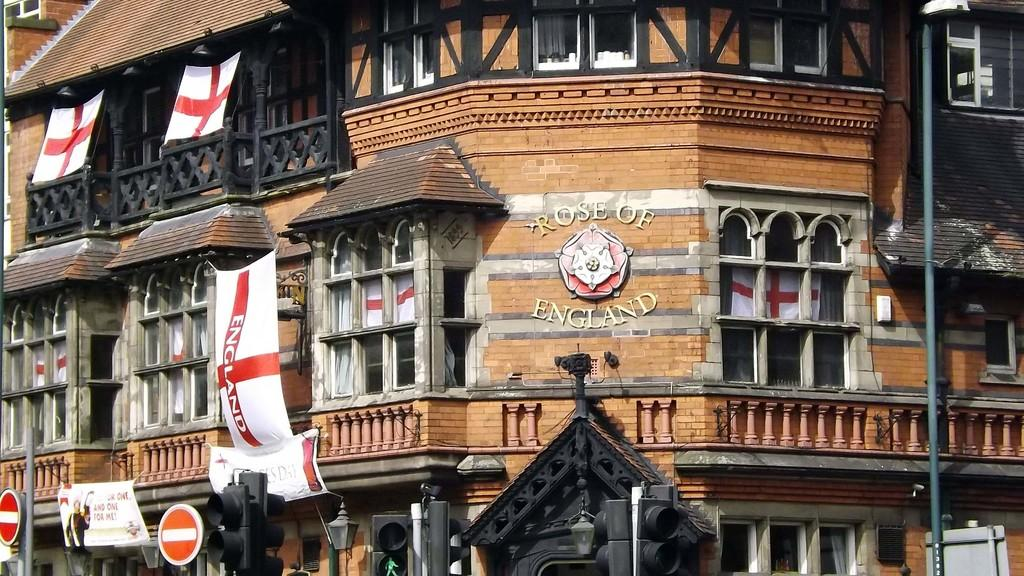<image>
Share a concise interpretation of the image provided. Brown building with "Rose of England" in the front. 